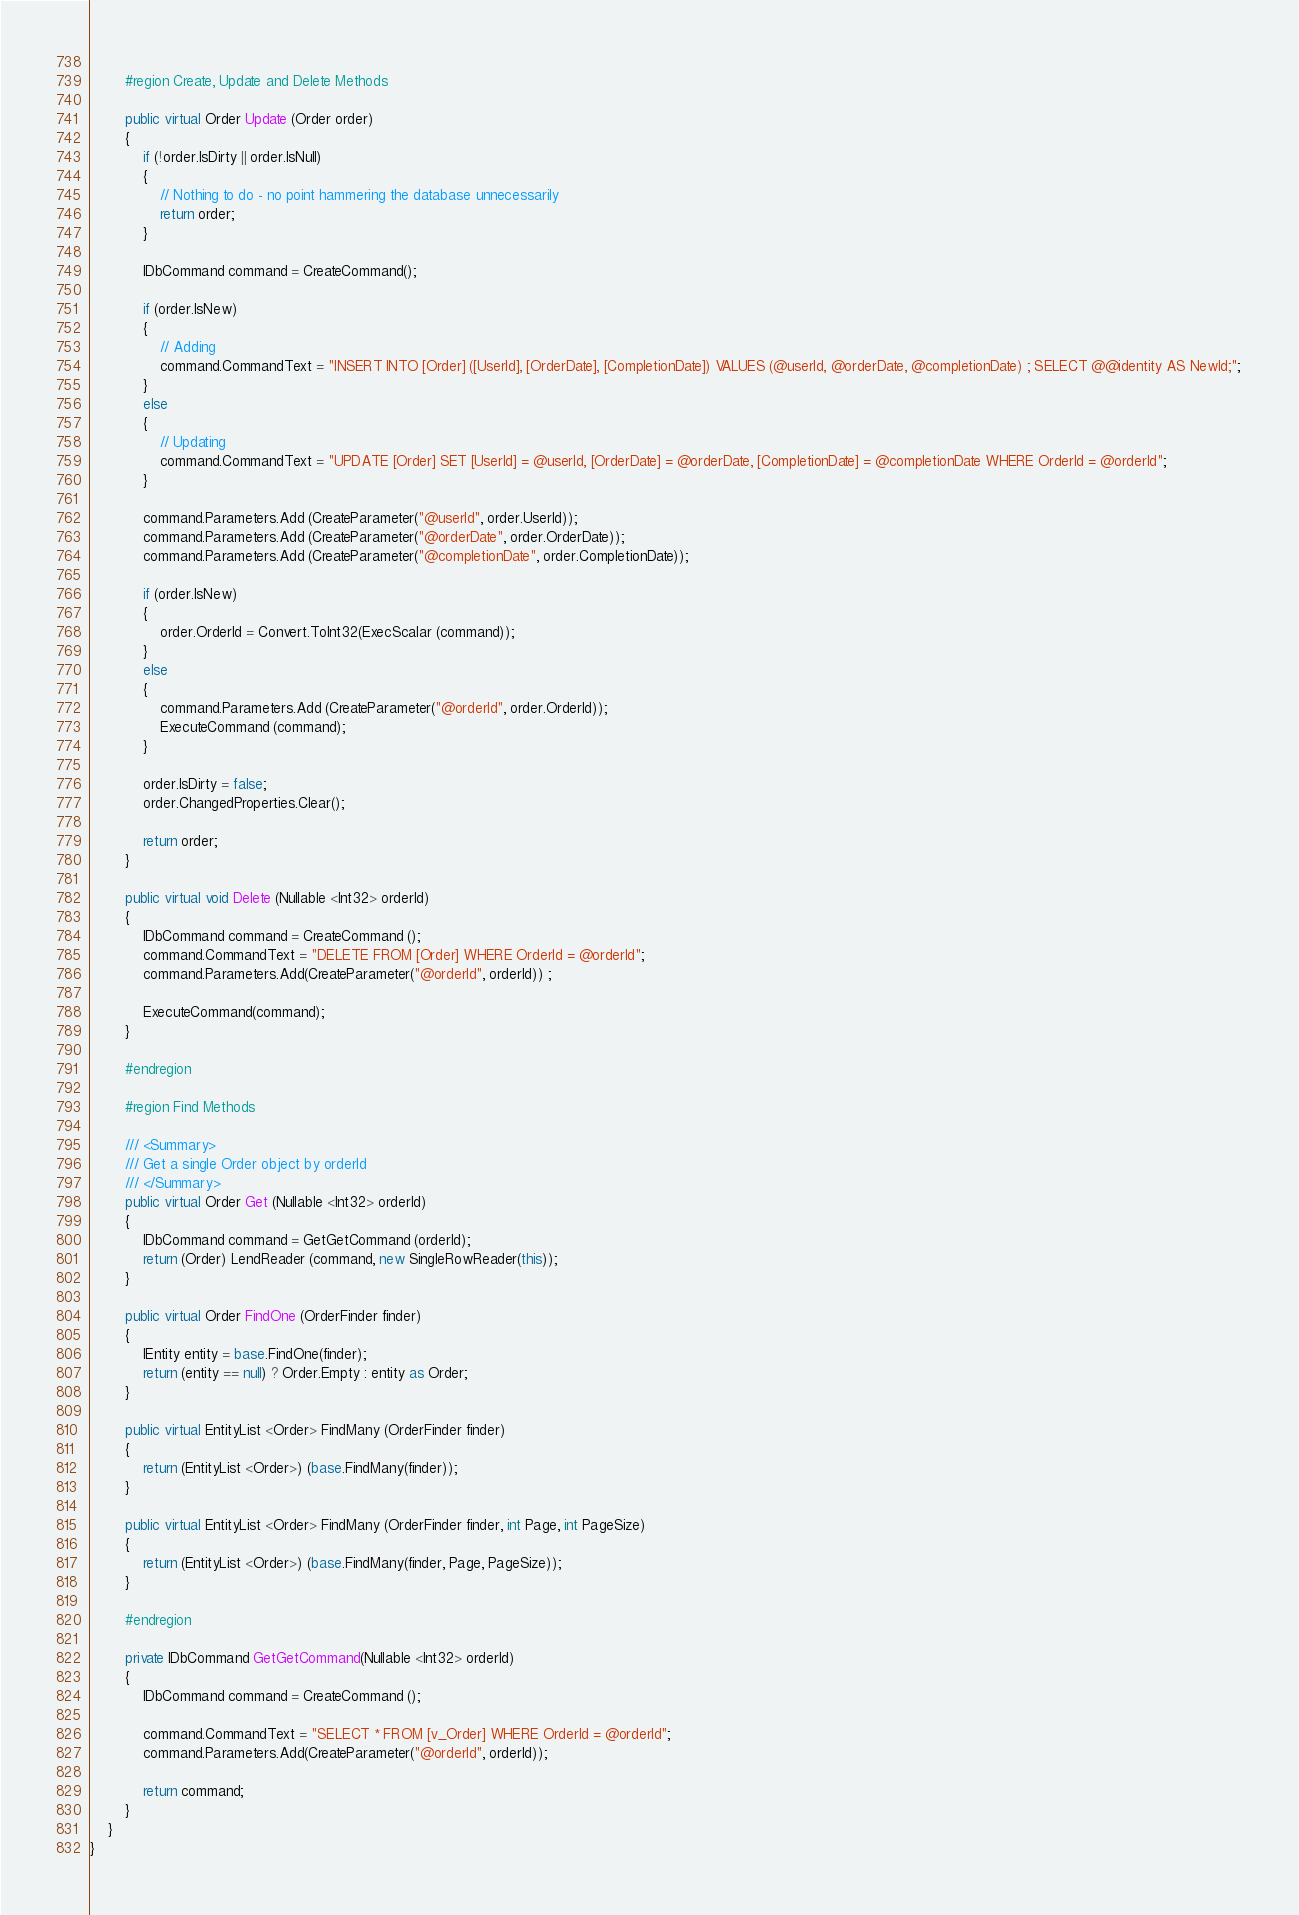<code> <loc_0><loc_0><loc_500><loc_500><_C#_>		
		#region Create, Update and Delete Methods
		
		public virtual Order Update (Order order)
		{
 			if (!order.IsDirty || order.IsNull)
			{
				// Nothing to do - no point hammering the database unnecessarily
				return order;
			}
			
			IDbCommand command = CreateCommand();
			
			if (order.IsNew) 
			{
				// Adding
				command.CommandText = "INSERT INTO [Order] ([UserId], [OrderDate], [CompletionDate]) VALUES (@userId, @orderDate, @completionDate) ; SELECT @@identity AS NewId;"; 
			}
			else 
			{
				// Updating
				command.CommandText = "UPDATE [Order] SET [UserId] = @userId, [OrderDate] = @orderDate, [CompletionDate] = @completionDate WHERE OrderId = @orderId"; 
			}
			
			command.Parameters.Add (CreateParameter("@userId", order.UserId));
			command.Parameters.Add (CreateParameter("@orderDate", order.OrderDate));
			command.Parameters.Add (CreateParameter("@completionDate", order.CompletionDate));

			if (order.IsNew) 
			{
				order.OrderId = Convert.ToInt32(ExecScalar (command));
			}
			else
			{
				command.Parameters.Add (CreateParameter("@orderId", order.OrderId));
				ExecuteCommand (command);
			}
			
			order.IsDirty = false;
			order.ChangedProperties.Clear();
			
			return order;
		}

		public virtual void Delete (Nullable <Int32> orderId)
		{
			IDbCommand command = CreateCommand ();
			command.CommandText = "DELETE FROM [Order] WHERE OrderId = @orderId";
			command.Parameters.Add(CreateParameter("@orderId", orderId)) ;

			ExecuteCommand(command);
		}
		
		#endregion

		#region Find Methods
		
		/// <Summary>
		/// Get a single Order object by orderId
		/// </Summary>
		public virtual Order Get (Nullable <Int32> orderId)
		{
			IDbCommand command = GetGetCommand (orderId);
			return (Order) LendReader (command, new SingleRowReader(this));
		}
		
		public virtual Order FindOne (OrderFinder finder)
		{
			IEntity entity = base.FindOne(finder);
			return (entity == null) ? Order.Empty : entity as Order;
		}
		
		public virtual EntityList <Order> FindMany (OrderFinder finder)
		{
			return (EntityList <Order>) (base.FindMany(finder));
		}

		public virtual EntityList <Order> FindMany (OrderFinder finder, int Page, int PageSize)
		{
			return (EntityList <Order>) (base.FindMany(finder, Page, PageSize));
		}
		
		#endregion
		
		private IDbCommand GetGetCommand(Nullable <Int32> orderId)
		{
			IDbCommand command = CreateCommand ();
			
			command.CommandText = "SELECT * FROM [v_Order] WHERE OrderId = @orderId";
			command.Parameters.Add(CreateParameter("@orderId", orderId)); 
			
			return command;
		}
	}
}

</code> 